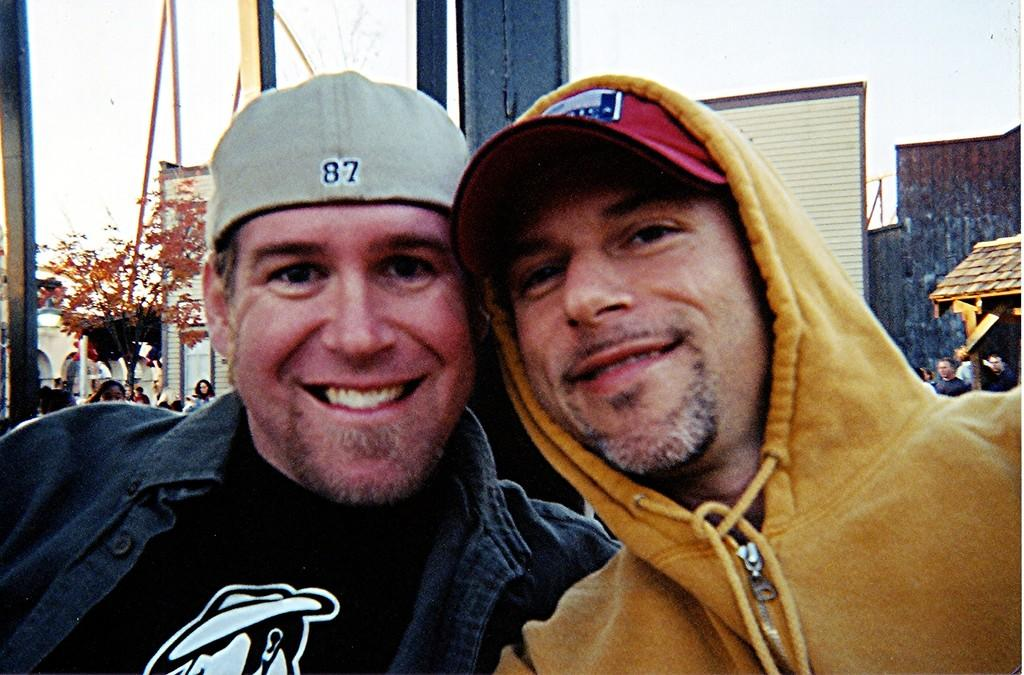How many people are in the front of the image? There are two people in the front of the image. What can be seen in the background of the image? In the background of the image, there is a tree, rods, walls, a roof, a building, a pole, people, and the sky. Can you describe the structure in the background? The structure in the background is a building with walls, a roof, and a pole. What else is visible in the background? In addition to the structure, there are people, a tree, rods, and the sky visible in the background. What type of unit is the governor discussing in the image? There is no governor or discussion present in the image. What scientific discovery is being made in the image? There is no scientific discovery being made in the image. 